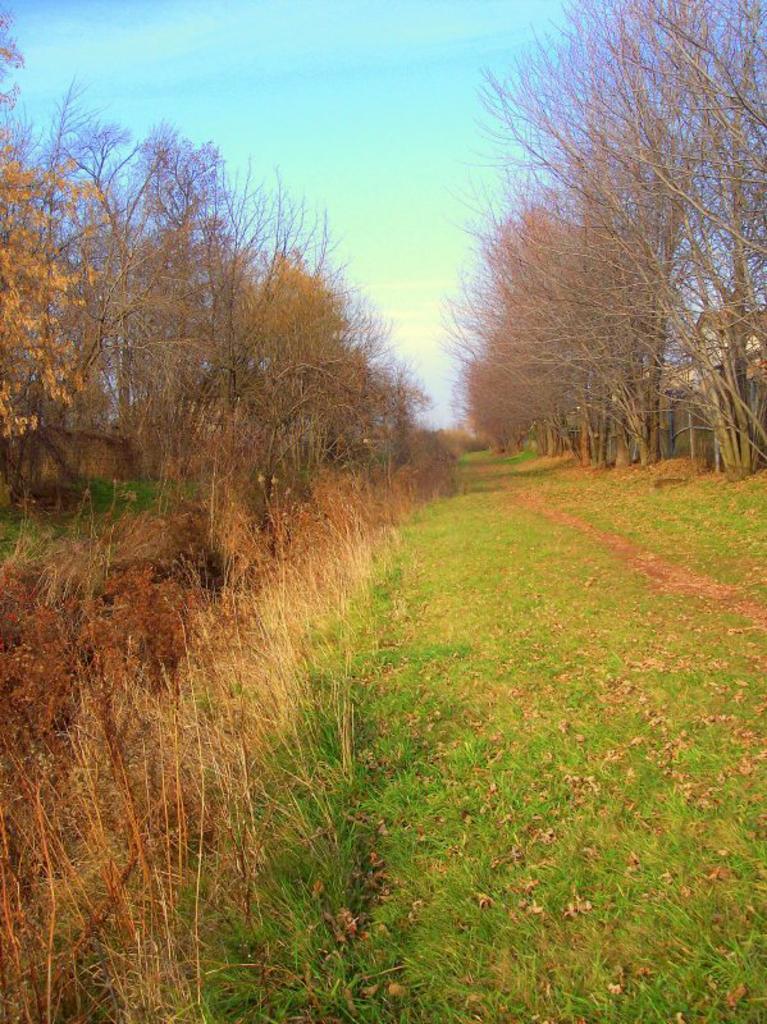Can you describe this image briefly? In the picture i can see grass, there are some trees on left and right side of the picture, top of the picture there is blue color sky. 